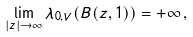<formula> <loc_0><loc_0><loc_500><loc_500>\lim _ { | z | \rightarrow \infty } \lambda _ { 0 , V } ( B ( z , 1 ) ) = + \infty \, ,</formula> 